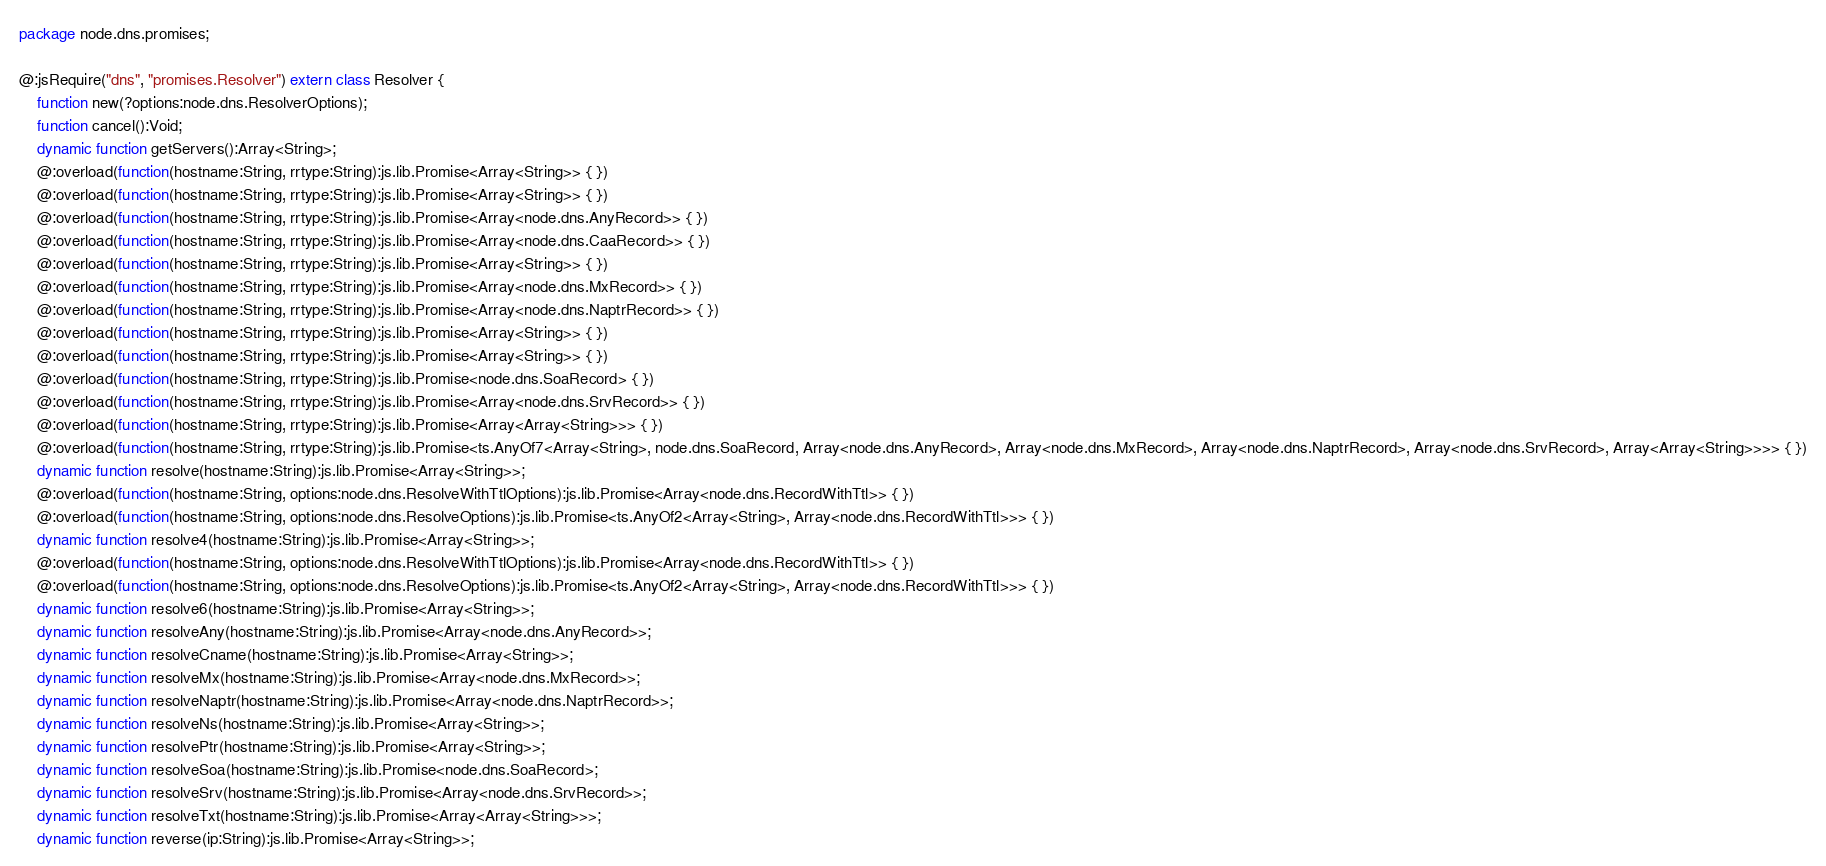<code> <loc_0><loc_0><loc_500><loc_500><_Haxe_>package node.dns.promises;

@:jsRequire("dns", "promises.Resolver") extern class Resolver {
	function new(?options:node.dns.ResolverOptions);
	function cancel():Void;
	dynamic function getServers():Array<String>;
	@:overload(function(hostname:String, rrtype:String):js.lib.Promise<Array<String>> { })
	@:overload(function(hostname:String, rrtype:String):js.lib.Promise<Array<String>> { })
	@:overload(function(hostname:String, rrtype:String):js.lib.Promise<Array<node.dns.AnyRecord>> { })
	@:overload(function(hostname:String, rrtype:String):js.lib.Promise<Array<node.dns.CaaRecord>> { })
	@:overload(function(hostname:String, rrtype:String):js.lib.Promise<Array<String>> { })
	@:overload(function(hostname:String, rrtype:String):js.lib.Promise<Array<node.dns.MxRecord>> { })
	@:overload(function(hostname:String, rrtype:String):js.lib.Promise<Array<node.dns.NaptrRecord>> { })
	@:overload(function(hostname:String, rrtype:String):js.lib.Promise<Array<String>> { })
	@:overload(function(hostname:String, rrtype:String):js.lib.Promise<Array<String>> { })
	@:overload(function(hostname:String, rrtype:String):js.lib.Promise<node.dns.SoaRecord> { })
	@:overload(function(hostname:String, rrtype:String):js.lib.Promise<Array<node.dns.SrvRecord>> { })
	@:overload(function(hostname:String, rrtype:String):js.lib.Promise<Array<Array<String>>> { })
	@:overload(function(hostname:String, rrtype:String):js.lib.Promise<ts.AnyOf7<Array<String>, node.dns.SoaRecord, Array<node.dns.AnyRecord>, Array<node.dns.MxRecord>, Array<node.dns.NaptrRecord>, Array<node.dns.SrvRecord>, Array<Array<String>>>> { })
	dynamic function resolve(hostname:String):js.lib.Promise<Array<String>>;
	@:overload(function(hostname:String, options:node.dns.ResolveWithTtlOptions):js.lib.Promise<Array<node.dns.RecordWithTtl>> { })
	@:overload(function(hostname:String, options:node.dns.ResolveOptions):js.lib.Promise<ts.AnyOf2<Array<String>, Array<node.dns.RecordWithTtl>>> { })
	dynamic function resolve4(hostname:String):js.lib.Promise<Array<String>>;
	@:overload(function(hostname:String, options:node.dns.ResolveWithTtlOptions):js.lib.Promise<Array<node.dns.RecordWithTtl>> { })
	@:overload(function(hostname:String, options:node.dns.ResolveOptions):js.lib.Promise<ts.AnyOf2<Array<String>, Array<node.dns.RecordWithTtl>>> { })
	dynamic function resolve6(hostname:String):js.lib.Promise<Array<String>>;
	dynamic function resolveAny(hostname:String):js.lib.Promise<Array<node.dns.AnyRecord>>;
	dynamic function resolveCname(hostname:String):js.lib.Promise<Array<String>>;
	dynamic function resolveMx(hostname:String):js.lib.Promise<Array<node.dns.MxRecord>>;
	dynamic function resolveNaptr(hostname:String):js.lib.Promise<Array<node.dns.NaptrRecord>>;
	dynamic function resolveNs(hostname:String):js.lib.Promise<Array<String>>;
	dynamic function resolvePtr(hostname:String):js.lib.Promise<Array<String>>;
	dynamic function resolveSoa(hostname:String):js.lib.Promise<node.dns.SoaRecord>;
	dynamic function resolveSrv(hostname:String):js.lib.Promise<Array<node.dns.SrvRecord>>;
	dynamic function resolveTxt(hostname:String):js.lib.Promise<Array<Array<String>>>;
	dynamic function reverse(ip:String):js.lib.Promise<Array<String>>;</code> 